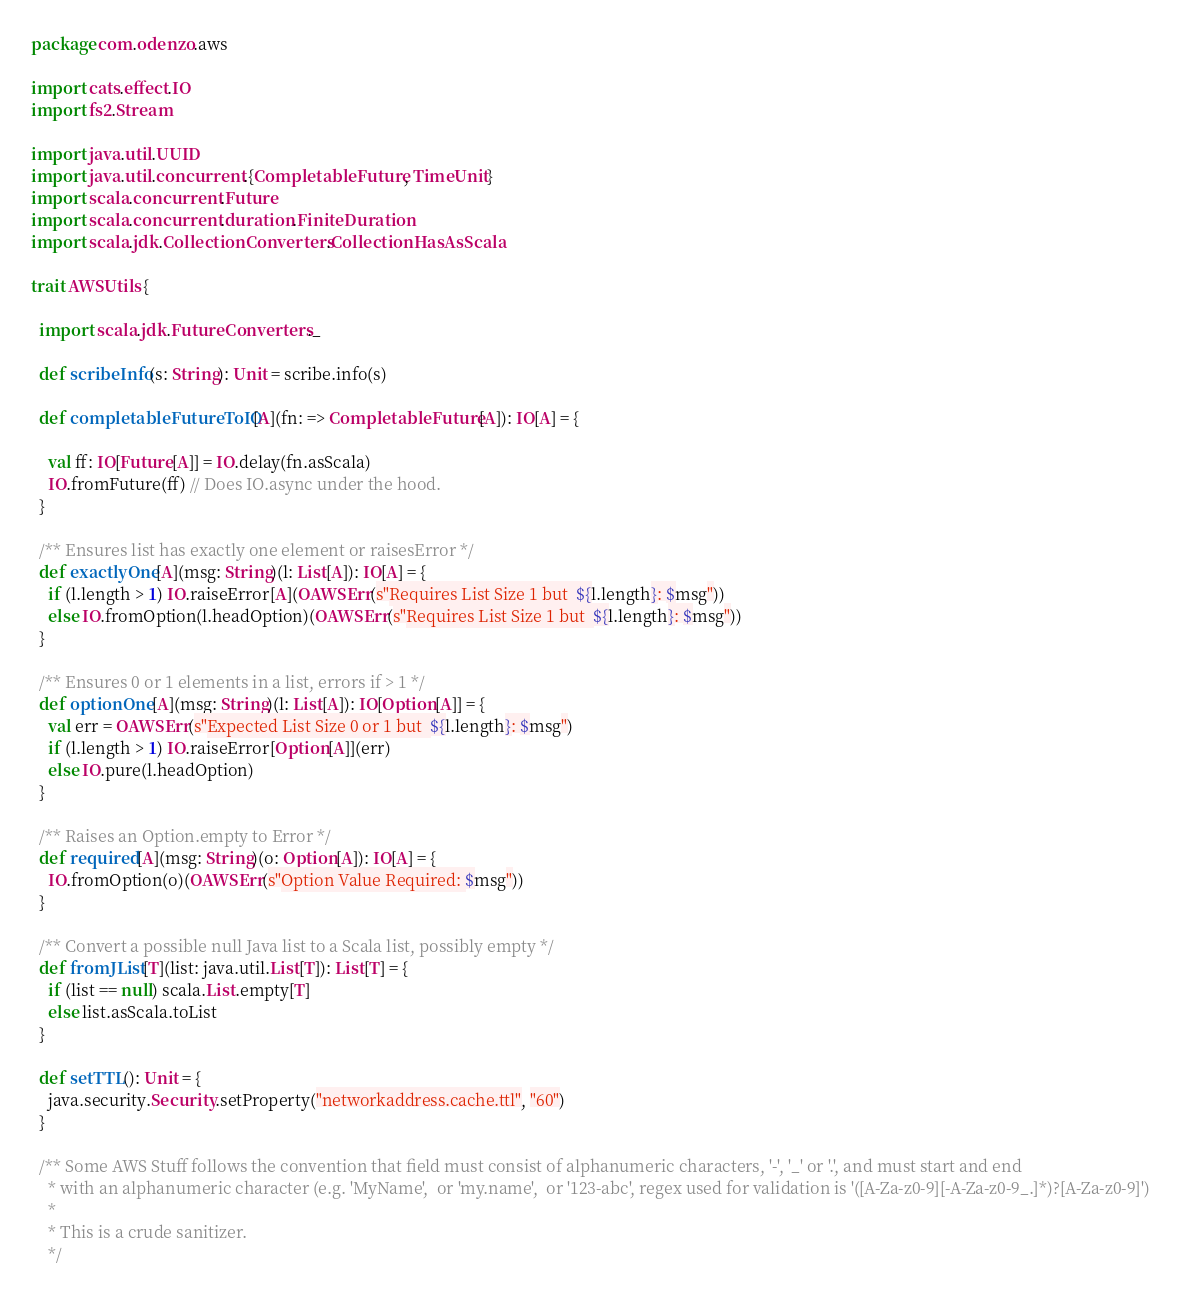Convert code to text. <code><loc_0><loc_0><loc_500><loc_500><_Scala_>package com.odenzo.aws

import cats.effect.IO
import fs2.Stream

import java.util.UUID
import java.util.concurrent.{CompletableFuture, TimeUnit}
import scala.concurrent.Future
import scala.concurrent.duration.FiniteDuration
import scala.jdk.CollectionConverters.CollectionHasAsScala

trait AWSUtils {

  import scala.jdk.FutureConverters._

  def scribeInfo(s: String): Unit = scribe.info(s)

  def completableFutureToIO[A](fn: => CompletableFuture[A]): IO[A] = {

    val ff: IO[Future[A]] = IO.delay(fn.asScala)
    IO.fromFuture(ff) // Does IO.async under the hood.
  }

  /** Ensures list has exactly one element or raisesError */
  def exactlyOne[A](msg: String)(l: List[A]): IO[A] = {
    if (l.length > 1) IO.raiseError[A](OAWSErr(s"Requires List Size 1 but  ${l.length}: $msg"))
    else IO.fromOption(l.headOption)(OAWSErr(s"Requires List Size 1 but  ${l.length}: $msg"))
  }

  /** Ensures 0 or 1 elements in a list, errors if > 1 */
  def optionOne[A](msg: String)(l: List[A]): IO[Option[A]] = {
    val err = OAWSErr(s"Expected List Size 0 or 1 but  ${l.length}: $msg")
    if (l.length > 1) IO.raiseError[Option[A]](err)
    else IO.pure(l.headOption)
  }

  /** Raises an Option.empty to Error */
  def required[A](msg: String)(o: Option[A]): IO[A] = {
    IO.fromOption(o)(OAWSErr(s"Option Value Required: $msg"))
  }

  /** Convert a possible null Java list to a Scala list, possibly empty */
  def fromJList[T](list: java.util.List[T]): List[T] = {
    if (list == null) scala.List.empty[T]
    else list.asScala.toList
  }

  def setTTL(): Unit = {
    java.security.Security.setProperty("networkaddress.cache.ttl", "60")
  }

  /** Some AWS Stuff follows the convention that field must consist of alphanumeric characters, '-', '_' or '.', and must start and end
    * with an alphanumeric character (e.g. 'MyName',  or 'my.name',  or '123-abc', regex used for validation is '([A-Za-z0-9][-A-Za-z0-9_.]*)?[A-Za-z0-9]')
    *
    * This is a crude sanitizer.
    */</code> 